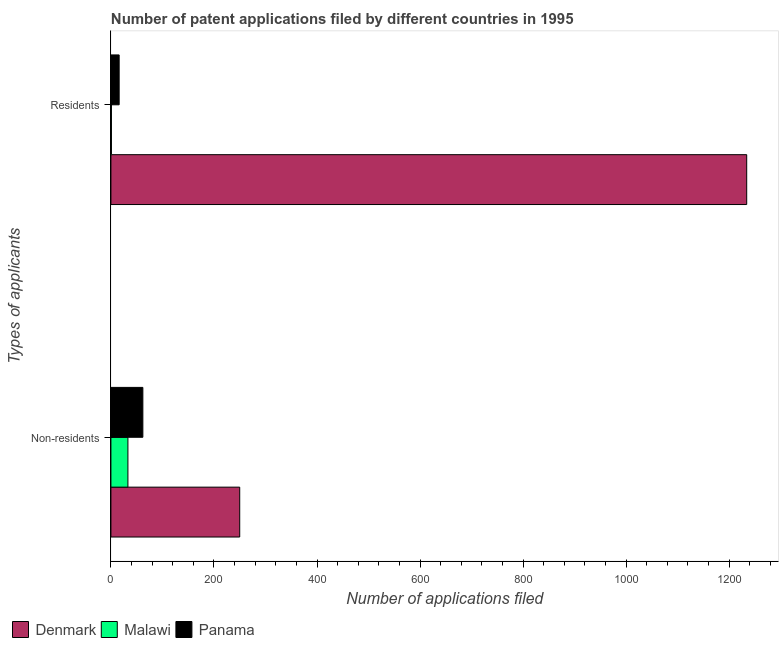How many different coloured bars are there?
Offer a terse response. 3. How many groups of bars are there?
Provide a succinct answer. 2. How many bars are there on the 2nd tick from the top?
Keep it short and to the point. 3. What is the label of the 2nd group of bars from the top?
Your answer should be compact. Non-residents. What is the number of patent applications by non residents in Malawi?
Give a very brief answer. 33. Across all countries, what is the maximum number of patent applications by residents?
Ensure brevity in your answer.  1234. Across all countries, what is the minimum number of patent applications by residents?
Your answer should be compact. 1. In which country was the number of patent applications by residents maximum?
Your answer should be compact. Denmark. In which country was the number of patent applications by non residents minimum?
Your answer should be compact. Malawi. What is the total number of patent applications by residents in the graph?
Ensure brevity in your answer.  1251. What is the difference between the number of patent applications by residents in Malawi and that in Panama?
Give a very brief answer. -15. What is the difference between the number of patent applications by residents in Malawi and the number of patent applications by non residents in Denmark?
Offer a terse response. -249. What is the average number of patent applications by non residents per country?
Provide a succinct answer. 115. What is the difference between the number of patent applications by residents and number of patent applications by non residents in Malawi?
Your answer should be compact. -32. In how many countries, is the number of patent applications by residents greater than 520 ?
Offer a terse response. 1. What is the ratio of the number of patent applications by non residents in Denmark to that in Malawi?
Ensure brevity in your answer.  7.58. Is the number of patent applications by residents in Panama less than that in Malawi?
Provide a short and direct response. No. In how many countries, is the number of patent applications by residents greater than the average number of patent applications by residents taken over all countries?
Provide a short and direct response. 1. What does the 2nd bar from the top in Non-residents represents?
Make the answer very short. Malawi. How many bars are there?
Offer a very short reply. 6. Are all the bars in the graph horizontal?
Offer a terse response. Yes. How many countries are there in the graph?
Your response must be concise. 3. Does the graph contain any zero values?
Keep it short and to the point. No. How are the legend labels stacked?
Make the answer very short. Horizontal. What is the title of the graph?
Ensure brevity in your answer.  Number of patent applications filed by different countries in 1995. What is the label or title of the X-axis?
Provide a short and direct response. Number of applications filed. What is the label or title of the Y-axis?
Your response must be concise. Types of applicants. What is the Number of applications filed of Denmark in Non-residents?
Offer a very short reply. 250. What is the Number of applications filed of Malawi in Non-residents?
Offer a terse response. 33. What is the Number of applications filed of Denmark in Residents?
Make the answer very short. 1234. What is the Number of applications filed of Malawi in Residents?
Ensure brevity in your answer.  1. Across all Types of applicants, what is the maximum Number of applications filed of Denmark?
Keep it short and to the point. 1234. Across all Types of applicants, what is the maximum Number of applications filed of Panama?
Your answer should be compact. 62. Across all Types of applicants, what is the minimum Number of applications filed in Denmark?
Your answer should be compact. 250. Across all Types of applicants, what is the minimum Number of applications filed of Malawi?
Your answer should be very brief. 1. What is the total Number of applications filed of Denmark in the graph?
Ensure brevity in your answer.  1484. What is the total Number of applications filed in Panama in the graph?
Ensure brevity in your answer.  78. What is the difference between the Number of applications filed in Denmark in Non-residents and that in Residents?
Offer a very short reply. -984. What is the difference between the Number of applications filed in Denmark in Non-residents and the Number of applications filed in Malawi in Residents?
Provide a short and direct response. 249. What is the difference between the Number of applications filed in Denmark in Non-residents and the Number of applications filed in Panama in Residents?
Make the answer very short. 234. What is the difference between the Number of applications filed of Malawi in Non-residents and the Number of applications filed of Panama in Residents?
Ensure brevity in your answer.  17. What is the average Number of applications filed of Denmark per Types of applicants?
Keep it short and to the point. 742. What is the average Number of applications filed in Panama per Types of applicants?
Make the answer very short. 39. What is the difference between the Number of applications filed of Denmark and Number of applications filed of Malawi in Non-residents?
Offer a very short reply. 217. What is the difference between the Number of applications filed in Denmark and Number of applications filed in Panama in Non-residents?
Your answer should be very brief. 188. What is the difference between the Number of applications filed in Denmark and Number of applications filed in Malawi in Residents?
Your answer should be compact. 1233. What is the difference between the Number of applications filed of Denmark and Number of applications filed of Panama in Residents?
Your response must be concise. 1218. What is the difference between the Number of applications filed in Malawi and Number of applications filed in Panama in Residents?
Your answer should be very brief. -15. What is the ratio of the Number of applications filed in Denmark in Non-residents to that in Residents?
Provide a succinct answer. 0.2. What is the ratio of the Number of applications filed in Panama in Non-residents to that in Residents?
Offer a terse response. 3.88. What is the difference between the highest and the second highest Number of applications filed of Denmark?
Offer a terse response. 984. What is the difference between the highest and the lowest Number of applications filed in Denmark?
Ensure brevity in your answer.  984. What is the difference between the highest and the lowest Number of applications filed in Malawi?
Offer a very short reply. 32. What is the difference between the highest and the lowest Number of applications filed in Panama?
Keep it short and to the point. 46. 